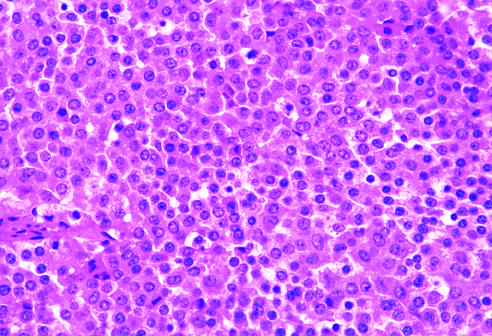how does the monomorphism of these cells contrast?
Answer the question using a single word or phrase. With admixture of cells seen in the normal anterior pituitary gland 